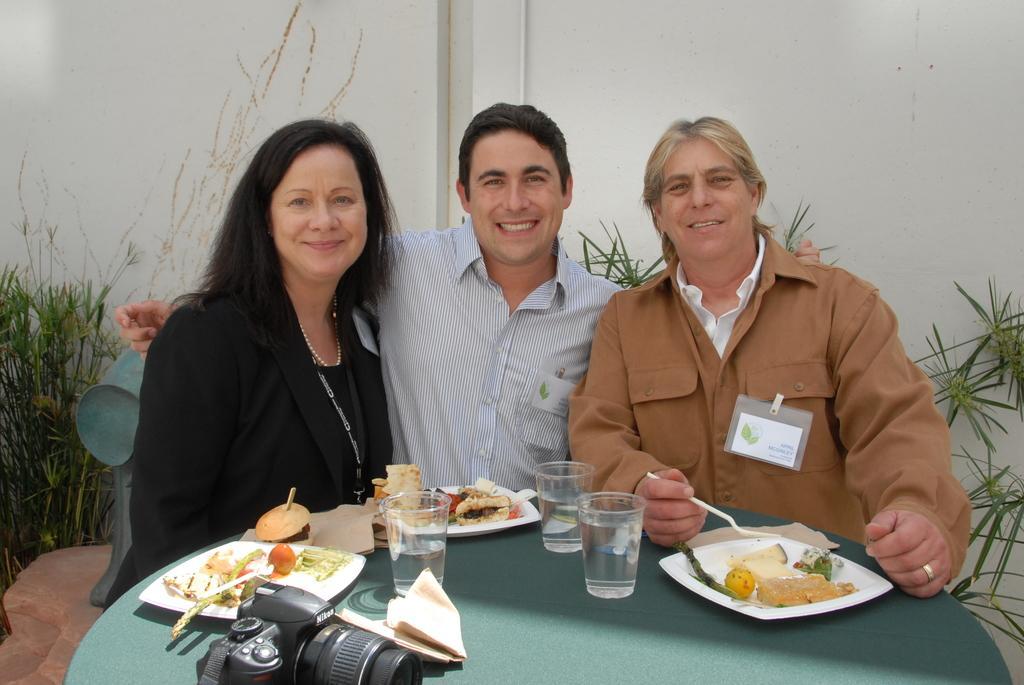Please provide a concise description of this image. Here we see three people seated with a smile on their faces. we see some plates with food On the table, and we see some glasses with water and a camera. 